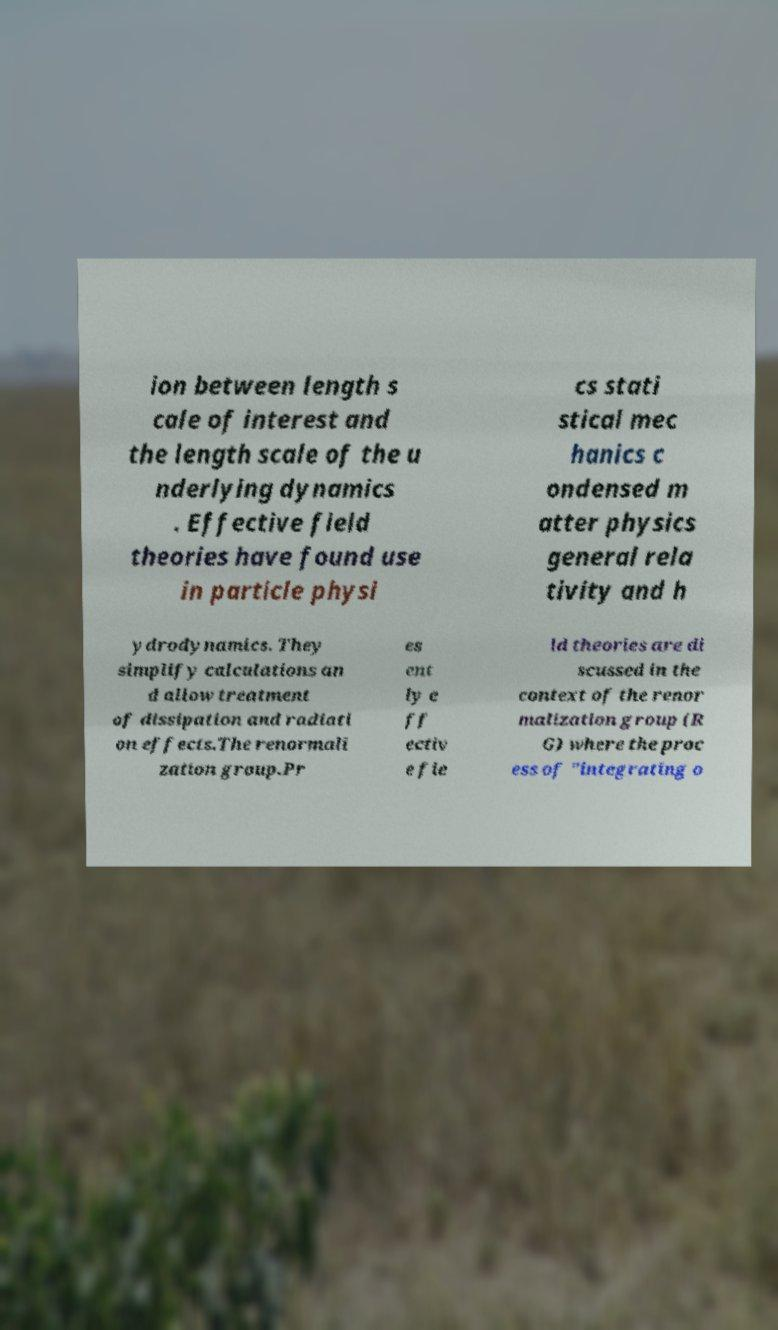Could you assist in decoding the text presented in this image and type it out clearly? ion between length s cale of interest and the length scale of the u nderlying dynamics . Effective field theories have found use in particle physi cs stati stical mec hanics c ondensed m atter physics general rela tivity and h ydrodynamics. They simplify calculations an d allow treatment of dissipation and radiati on effects.The renormali zation group.Pr es ent ly e ff ectiv e fie ld theories are di scussed in the context of the renor malization group (R G) where the proc ess of "integrating o 